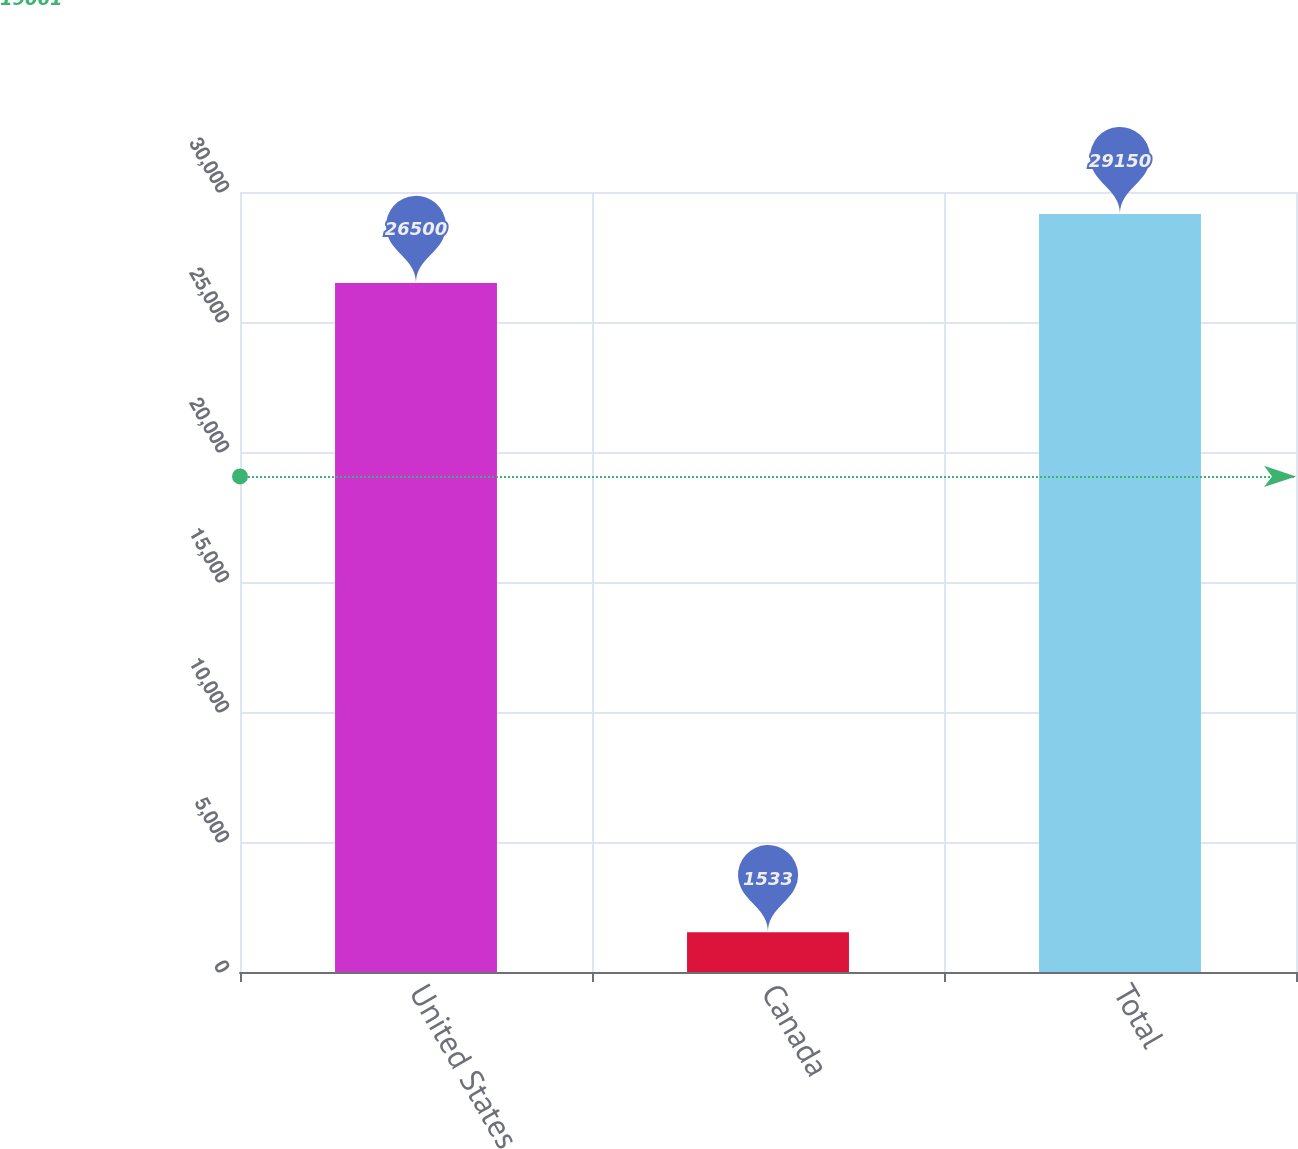<chart> <loc_0><loc_0><loc_500><loc_500><bar_chart><fcel>United States<fcel>Canada<fcel>Total<nl><fcel>26500<fcel>1533<fcel>29150<nl></chart> 